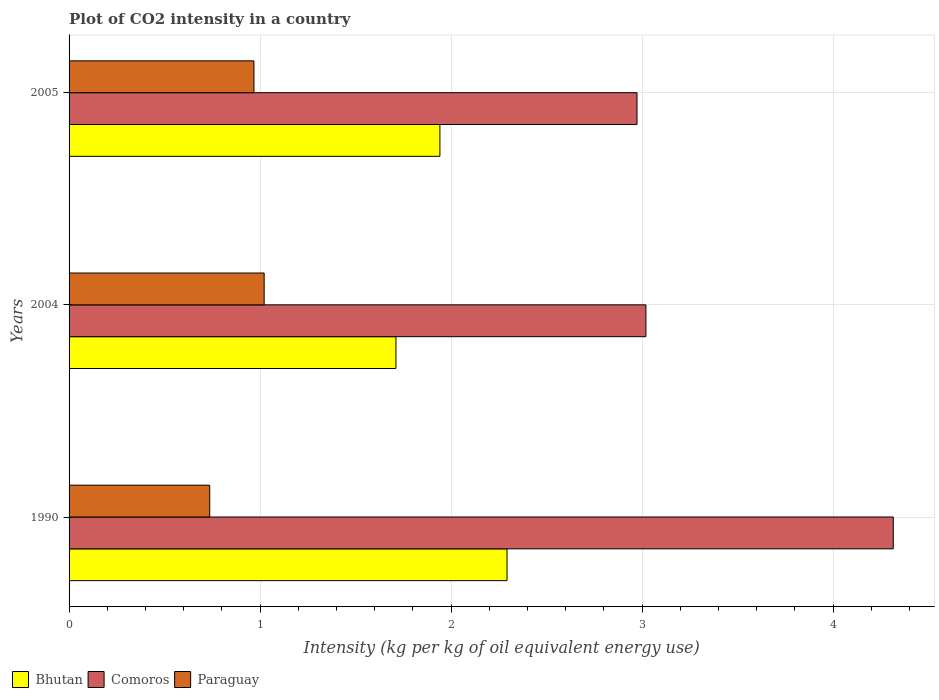How many different coloured bars are there?
Make the answer very short. 3. Are the number of bars per tick equal to the number of legend labels?
Your answer should be compact. Yes. Are the number of bars on each tick of the Y-axis equal?
Your answer should be compact. Yes. How many bars are there on the 3rd tick from the top?
Provide a succinct answer. 3. How many bars are there on the 3rd tick from the bottom?
Your response must be concise. 3. What is the label of the 3rd group of bars from the top?
Provide a succinct answer. 1990. What is the CO2 intensity in in Paraguay in 2004?
Your answer should be compact. 1.02. Across all years, what is the maximum CO2 intensity in in Paraguay?
Your answer should be compact. 1.02. Across all years, what is the minimum CO2 intensity in in Bhutan?
Your response must be concise. 1.71. What is the total CO2 intensity in in Paraguay in the graph?
Provide a succinct answer. 2.73. What is the difference between the CO2 intensity in in Bhutan in 1990 and that in 2004?
Ensure brevity in your answer.  0.58. What is the difference between the CO2 intensity in in Comoros in 2004 and the CO2 intensity in in Bhutan in 1990?
Give a very brief answer. 0.73. What is the average CO2 intensity in in Paraguay per year?
Keep it short and to the point. 0.91. In the year 2004, what is the difference between the CO2 intensity in in Bhutan and CO2 intensity in in Paraguay?
Your response must be concise. 0.69. In how many years, is the CO2 intensity in in Bhutan greater than 0.4 kg?
Your answer should be very brief. 3. What is the ratio of the CO2 intensity in in Comoros in 1990 to that in 2005?
Your response must be concise. 1.45. Is the CO2 intensity in in Comoros in 1990 less than that in 2005?
Ensure brevity in your answer.  No. Is the difference between the CO2 intensity in in Bhutan in 1990 and 2005 greater than the difference between the CO2 intensity in in Paraguay in 1990 and 2005?
Offer a terse response. Yes. What is the difference between the highest and the second highest CO2 intensity in in Paraguay?
Ensure brevity in your answer.  0.05. What is the difference between the highest and the lowest CO2 intensity in in Comoros?
Offer a very short reply. 1.34. What does the 3rd bar from the top in 1990 represents?
Ensure brevity in your answer.  Bhutan. What does the 3rd bar from the bottom in 1990 represents?
Your response must be concise. Paraguay. How many bars are there?
Offer a terse response. 9. Are all the bars in the graph horizontal?
Keep it short and to the point. Yes. How many years are there in the graph?
Your answer should be compact. 3. What is the difference between two consecutive major ticks on the X-axis?
Offer a very short reply. 1. Does the graph contain any zero values?
Your answer should be very brief. No. Does the graph contain grids?
Offer a very short reply. Yes. Where does the legend appear in the graph?
Provide a short and direct response. Bottom left. How are the legend labels stacked?
Offer a terse response. Horizontal. What is the title of the graph?
Give a very brief answer. Plot of CO2 intensity in a country. What is the label or title of the X-axis?
Your answer should be very brief. Intensity (kg per kg of oil equivalent energy use). What is the label or title of the Y-axis?
Offer a terse response. Years. What is the Intensity (kg per kg of oil equivalent energy use) in Bhutan in 1990?
Keep it short and to the point. 2.29. What is the Intensity (kg per kg of oil equivalent energy use) in Comoros in 1990?
Offer a very short reply. 4.31. What is the Intensity (kg per kg of oil equivalent energy use) in Paraguay in 1990?
Make the answer very short. 0.74. What is the Intensity (kg per kg of oil equivalent energy use) of Bhutan in 2004?
Keep it short and to the point. 1.71. What is the Intensity (kg per kg of oil equivalent energy use) in Comoros in 2004?
Offer a very short reply. 3.02. What is the Intensity (kg per kg of oil equivalent energy use) in Paraguay in 2004?
Provide a succinct answer. 1.02. What is the Intensity (kg per kg of oil equivalent energy use) in Bhutan in 2005?
Your answer should be very brief. 1.94. What is the Intensity (kg per kg of oil equivalent energy use) in Comoros in 2005?
Your response must be concise. 2.97. What is the Intensity (kg per kg of oil equivalent energy use) in Paraguay in 2005?
Provide a succinct answer. 0.97. Across all years, what is the maximum Intensity (kg per kg of oil equivalent energy use) in Bhutan?
Your response must be concise. 2.29. Across all years, what is the maximum Intensity (kg per kg of oil equivalent energy use) of Comoros?
Give a very brief answer. 4.31. Across all years, what is the maximum Intensity (kg per kg of oil equivalent energy use) of Paraguay?
Keep it short and to the point. 1.02. Across all years, what is the minimum Intensity (kg per kg of oil equivalent energy use) of Bhutan?
Give a very brief answer. 1.71. Across all years, what is the minimum Intensity (kg per kg of oil equivalent energy use) of Comoros?
Offer a terse response. 2.97. Across all years, what is the minimum Intensity (kg per kg of oil equivalent energy use) of Paraguay?
Provide a short and direct response. 0.74. What is the total Intensity (kg per kg of oil equivalent energy use) in Bhutan in the graph?
Provide a succinct answer. 5.95. What is the total Intensity (kg per kg of oil equivalent energy use) in Comoros in the graph?
Keep it short and to the point. 10.31. What is the total Intensity (kg per kg of oil equivalent energy use) of Paraguay in the graph?
Make the answer very short. 2.73. What is the difference between the Intensity (kg per kg of oil equivalent energy use) of Bhutan in 1990 and that in 2004?
Offer a very short reply. 0.58. What is the difference between the Intensity (kg per kg of oil equivalent energy use) of Comoros in 1990 and that in 2004?
Keep it short and to the point. 1.29. What is the difference between the Intensity (kg per kg of oil equivalent energy use) in Paraguay in 1990 and that in 2004?
Your answer should be compact. -0.28. What is the difference between the Intensity (kg per kg of oil equivalent energy use) of Bhutan in 1990 and that in 2005?
Keep it short and to the point. 0.35. What is the difference between the Intensity (kg per kg of oil equivalent energy use) of Comoros in 1990 and that in 2005?
Provide a succinct answer. 1.34. What is the difference between the Intensity (kg per kg of oil equivalent energy use) in Paraguay in 1990 and that in 2005?
Offer a terse response. -0.23. What is the difference between the Intensity (kg per kg of oil equivalent energy use) of Bhutan in 2004 and that in 2005?
Provide a short and direct response. -0.23. What is the difference between the Intensity (kg per kg of oil equivalent energy use) of Comoros in 2004 and that in 2005?
Your answer should be compact. 0.05. What is the difference between the Intensity (kg per kg of oil equivalent energy use) of Paraguay in 2004 and that in 2005?
Ensure brevity in your answer.  0.05. What is the difference between the Intensity (kg per kg of oil equivalent energy use) of Bhutan in 1990 and the Intensity (kg per kg of oil equivalent energy use) of Comoros in 2004?
Keep it short and to the point. -0.73. What is the difference between the Intensity (kg per kg of oil equivalent energy use) in Bhutan in 1990 and the Intensity (kg per kg of oil equivalent energy use) in Paraguay in 2004?
Your response must be concise. 1.27. What is the difference between the Intensity (kg per kg of oil equivalent energy use) of Comoros in 1990 and the Intensity (kg per kg of oil equivalent energy use) of Paraguay in 2004?
Offer a very short reply. 3.29. What is the difference between the Intensity (kg per kg of oil equivalent energy use) in Bhutan in 1990 and the Intensity (kg per kg of oil equivalent energy use) in Comoros in 2005?
Offer a very short reply. -0.68. What is the difference between the Intensity (kg per kg of oil equivalent energy use) in Bhutan in 1990 and the Intensity (kg per kg of oil equivalent energy use) in Paraguay in 2005?
Offer a terse response. 1.33. What is the difference between the Intensity (kg per kg of oil equivalent energy use) in Comoros in 1990 and the Intensity (kg per kg of oil equivalent energy use) in Paraguay in 2005?
Provide a short and direct response. 3.35. What is the difference between the Intensity (kg per kg of oil equivalent energy use) of Bhutan in 2004 and the Intensity (kg per kg of oil equivalent energy use) of Comoros in 2005?
Ensure brevity in your answer.  -1.26. What is the difference between the Intensity (kg per kg of oil equivalent energy use) of Bhutan in 2004 and the Intensity (kg per kg of oil equivalent energy use) of Paraguay in 2005?
Your answer should be compact. 0.74. What is the difference between the Intensity (kg per kg of oil equivalent energy use) in Comoros in 2004 and the Intensity (kg per kg of oil equivalent energy use) in Paraguay in 2005?
Ensure brevity in your answer.  2.05. What is the average Intensity (kg per kg of oil equivalent energy use) in Bhutan per year?
Provide a succinct answer. 1.98. What is the average Intensity (kg per kg of oil equivalent energy use) in Comoros per year?
Provide a short and direct response. 3.44. What is the average Intensity (kg per kg of oil equivalent energy use) in Paraguay per year?
Provide a succinct answer. 0.91. In the year 1990, what is the difference between the Intensity (kg per kg of oil equivalent energy use) in Bhutan and Intensity (kg per kg of oil equivalent energy use) in Comoros?
Provide a succinct answer. -2.02. In the year 1990, what is the difference between the Intensity (kg per kg of oil equivalent energy use) of Bhutan and Intensity (kg per kg of oil equivalent energy use) of Paraguay?
Offer a terse response. 1.56. In the year 1990, what is the difference between the Intensity (kg per kg of oil equivalent energy use) of Comoros and Intensity (kg per kg of oil equivalent energy use) of Paraguay?
Give a very brief answer. 3.58. In the year 2004, what is the difference between the Intensity (kg per kg of oil equivalent energy use) in Bhutan and Intensity (kg per kg of oil equivalent energy use) in Comoros?
Your answer should be compact. -1.31. In the year 2004, what is the difference between the Intensity (kg per kg of oil equivalent energy use) in Bhutan and Intensity (kg per kg of oil equivalent energy use) in Paraguay?
Offer a terse response. 0.69. In the year 2004, what is the difference between the Intensity (kg per kg of oil equivalent energy use) of Comoros and Intensity (kg per kg of oil equivalent energy use) of Paraguay?
Give a very brief answer. 2. In the year 2005, what is the difference between the Intensity (kg per kg of oil equivalent energy use) of Bhutan and Intensity (kg per kg of oil equivalent energy use) of Comoros?
Offer a terse response. -1.03. In the year 2005, what is the difference between the Intensity (kg per kg of oil equivalent energy use) in Bhutan and Intensity (kg per kg of oil equivalent energy use) in Paraguay?
Ensure brevity in your answer.  0.97. In the year 2005, what is the difference between the Intensity (kg per kg of oil equivalent energy use) of Comoros and Intensity (kg per kg of oil equivalent energy use) of Paraguay?
Provide a succinct answer. 2.01. What is the ratio of the Intensity (kg per kg of oil equivalent energy use) in Bhutan in 1990 to that in 2004?
Your answer should be very brief. 1.34. What is the ratio of the Intensity (kg per kg of oil equivalent energy use) of Comoros in 1990 to that in 2004?
Make the answer very short. 1.43. What is the ratio of the Intensity (kg per kg of oil equivalent energy use) in Paraguay in 1990 to that in 2004?
Provide a short and direct response. 0.72. What is the ratio of the Intensity (kg per kg of oil equivalent energy use) in Bhutan in 1990 to that in 2005?
Give a very brief answer. 1.18. What is the ratio of the Intensity (kg per kg of oil equivalent energy use) of Comoros in 1990 to that in 2005?
Your response must be concise. 1.45. What is the ratio of the Intensity (kg per kg of oil equivalent energy use) in Paraguay in 1990 to that in 2005?
Keep it short and to the point. 0.76. What is the ratio of the Intensity (kg per kg of oil equivalent energy use) in Bhutan in 2004 to that in 2005?
Your answer should be very brief. 0.88. What is the ratio of the Intensity (kg per kg of oil equivalent energy use) of Comoros in 2004 to that in 2005?
Offer a very short reply. 1.02. What is the ratio of the Intensity (kg per kg of oil equivalent energy use) of Paraguay in 2004 to that in 2005?
Your answer should be compact. 1.06. What is the difference between the highest and the second highest Intensity (kg per kg of oil equivalent energy use) in Bhutan?
Provide a short and direct response. 0.35. What is the difference between the highest and the second highest Intensity (kg per kg of oil equivalent energy use) in Comoros?
Ensure brevity in your answer.  1.29. What is the difference between the highest and the second highest Intensity (kg per kg of oil equivalent energy use) of Paraguay?
Make the answer very short. 0.05. What is the difference between the highest and the lowest Intensity (kg per kg of oil equivalent energy use) in Bhutan?
Offer a terse response. 0.58. What is the difference between the highest and the lowest Intensity (kg per kg of oil equivalent energy use) of Comoros?
Provide a short and direct response. 1.34. What is the difference between the highest and the lowest Intensity (kg per kg of oil equivalent energy use) in Paraguay?
Your answer should be very brief. 0.28. 